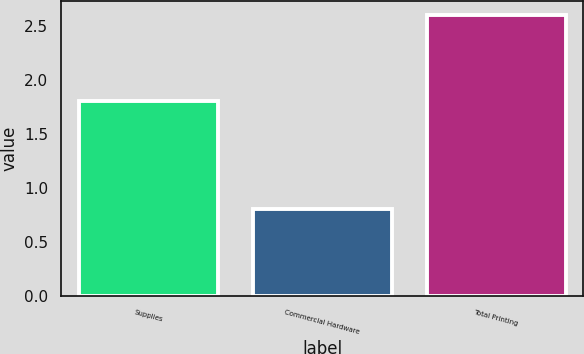<chart> <loc_0><loc_0><loc_500><loc_500><bar_chart><fcel>Supplies<fcel>Commercial Hardware<fcel>Total Printing<nl><fcel>1.8<fcel>0.8<fcel>2.6<nl></chart> 